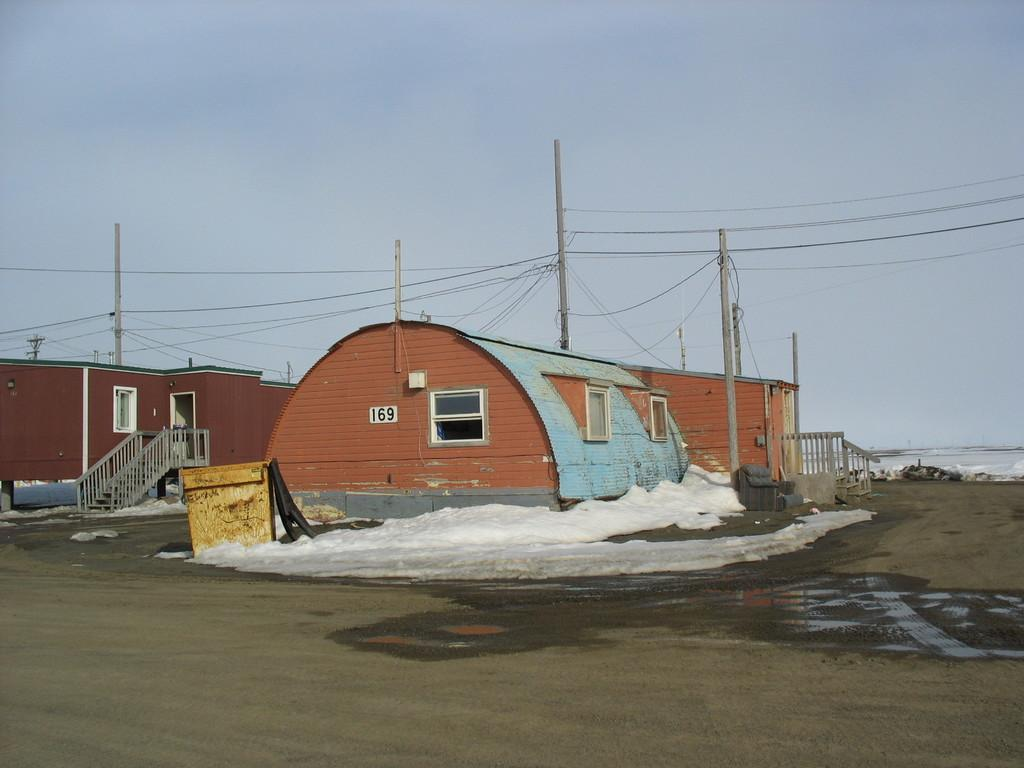What type of surface can be seen in the image? There is ground visible in the image. What type of structures are present in the image? There are houses in the image. What are the poles and wires associated with in the image? The poles and wires are likely associated with electrical or communication infrastructure. What architectural features can be seen on the houses? There are windows and railings visible on the houses. What else can be seen in the image besides the houses and infrastructure? There are objects in the image. What is visible in the background of the image? The sky is visible in the background of the image. Can you tell me how many roses are in the image? There are no roses present in the image. What position does the house hold in relation to the poles and wires? The position of the house in relation to the poles and wires cannot be determined from the image alone, as there is no reference point provided. 